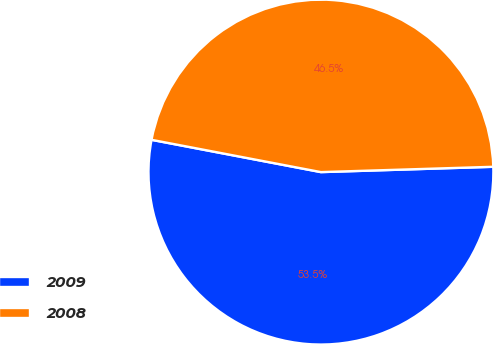Convert chart. <chart><loc_0><loc_0><loc_500><loc_500><pie_chart><fcel>2009<fcel>2008<nl><fcel>53.49%<fcel>46.51%<nl></chart> 